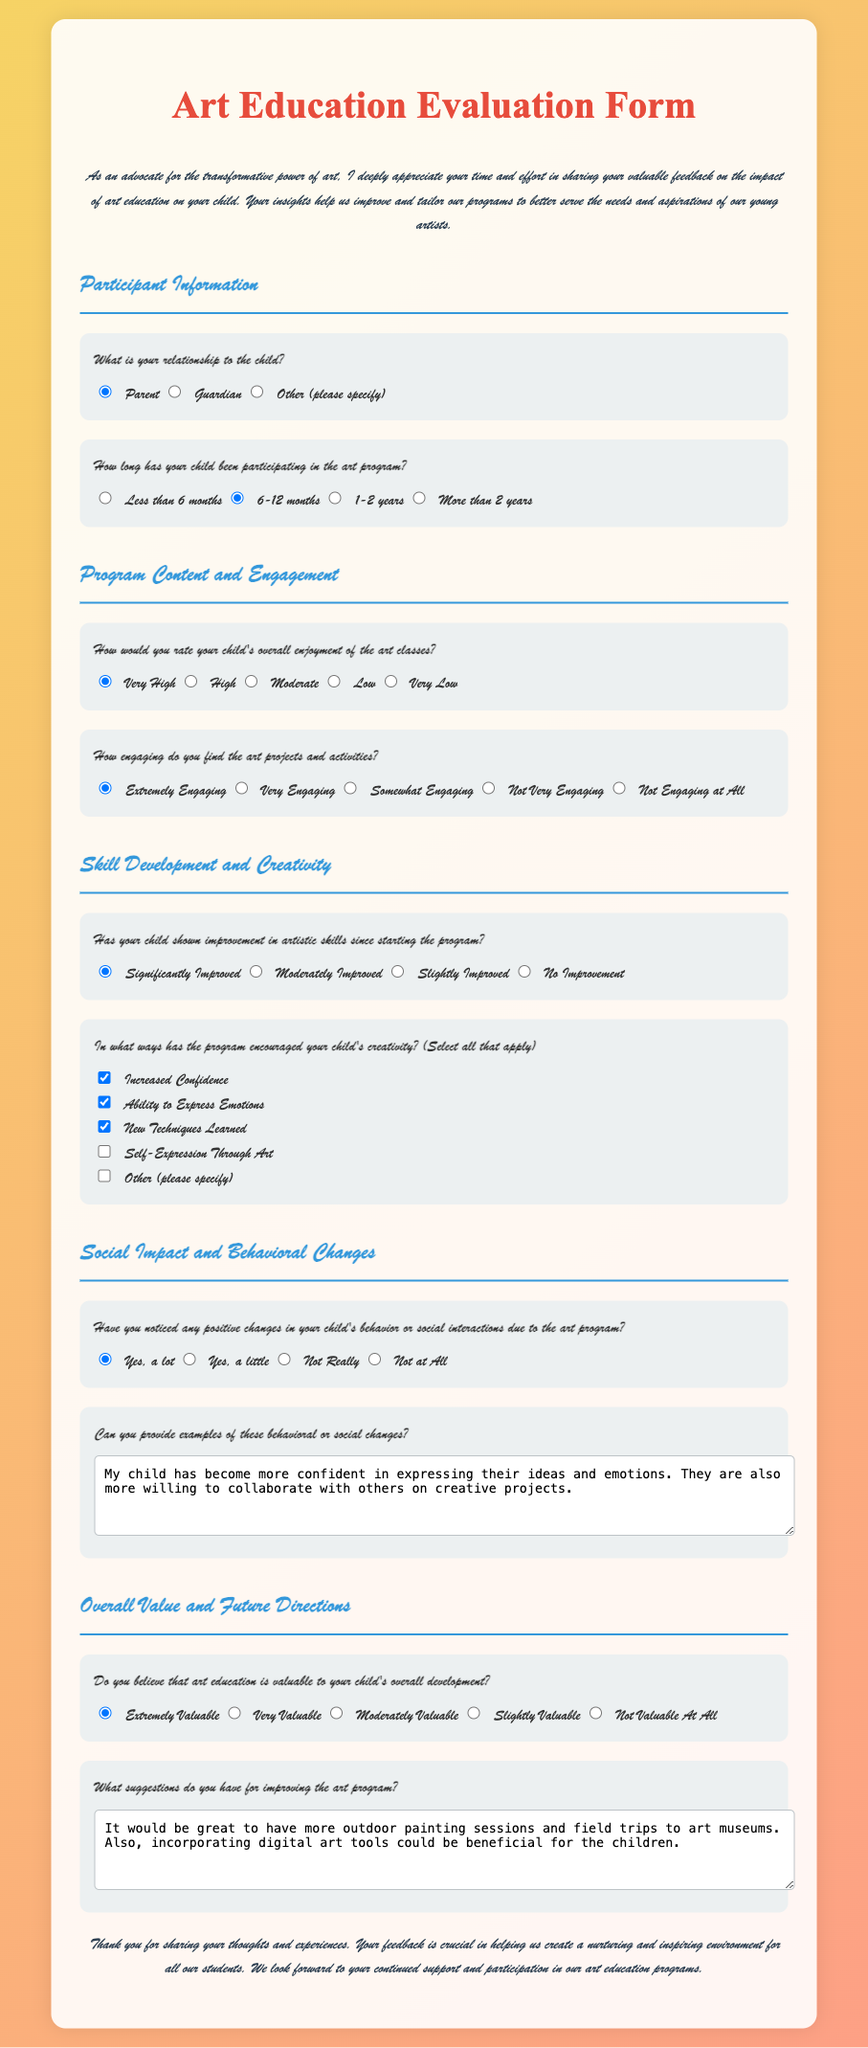What is the title of the document? The title of the document is given in the HTML <title> tag, which is "Art Education Evaluation Form."
Answer: Art Education Evaluation Form What is the relationship option that is pre-selected? The pre-selected option for the relationship question is indicated by the "checked" attribute in the radio input, which is "Parent."
Answer: Parent How long has the child been participating in the art program according to the checked option? The checked option for the duration indicates the time period selected for their child's participation, which is "6-12 months."
Answer: 6-12 months What rating is given for the child's overall enjoyment of the art classes? The rating for overall enjoyment is indicated by the selected radio button with the "checked" attribute, which is "Very High."
Answer: Very High What is one way the program has encouraged a child's creativity, as indicated in the checkboxes? The checkbox options indicate various ways, and one selected option is "Increased Confidence."
Answer: Increased Confidence Is there an indication of whether the art education is valuable for the child's development? The response shows that the selected rating of value for art education is "Extremely Valuable."
Answer: Extremely Valuable What suggestion is provided for improving the art program? The provided suggestion indicates an idea mentioned in the text area, specifically "more outdoor painting sessions and field trips to art museums."
Answer: more outdoor painting sessions and field trips to art museums What response method is employed for the question regarding positive changes in behavior? The response method for this particular question is indicated by the radio input, which presents options for selection.
Answer: Radio input How does the document suggest thanking participants for their feedback? The text in the conclusion section indicates appreciation for the time spent providing feedback and emphasizes its importance.
Answer: Thank you for sharing your thoughts and experiences 